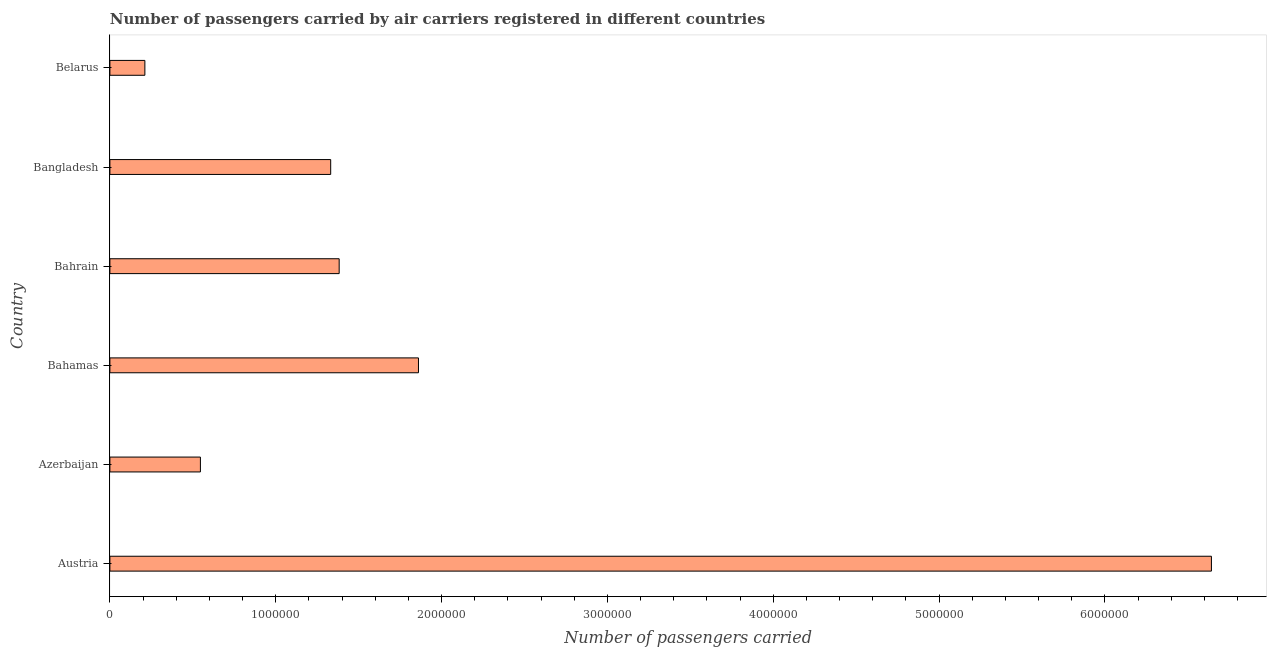Does the graph contain grids?
Give a very brief answer. No. What is the title of the graph?
Ensure brevity in your answer.  Number of passengers carried by air carriers registered in different countries. What is the label or title of the X-axis?
Your response must be concise. Number of passengers carried. What is the number of passengers carried in Azerbaijan?
Give a very brief answer. 5.46e+05. Across all countries, what is the maximum number of passengers carried?
Ensure brevity in your answer.  6.64e+06. Across all countries, what is the minimum number of passengers carried?
Give a very brief answer. 2.11e+05. In which country was the number of passengers carried maximum?
Provide a succinct answer. Austria. In which country was the number of passengers carried minimum?
Provide a succinct answer. Belarus. What is the sum of the number of passengers carried?
Provide a short and direct response. 1.20e+07. What is the difference between the number of passengers carried in Austria and Bahamas?
Keep it short and to the point. 4.78e+06. What is the average number of passengers carried per country?
Your response must be concise. 2.00e+06. What is the median number of passengers carried?
Make the answer very short. 1.36e+06. In how many countries, is the number of passengers carried greater than 6400000 ?
Keep it short and to the point. 1. What is the ratio of the number of passengers carried in Azerbaijan to that in Belarus?
Keep it short and to the point. 2.59. Is the number of passengers carried in Bangladesh less than that in Belarus?
Keep it short and to the point. No. Is the difference between the number of passengers carried in Bahamas and Bahrain greater than the difference between any two countries?
Provide a short and direct response. No. What is the difference between the highest and the second highest number of passengers carried?
Make the answer very short. 4.78e+06. What is the difference between the highest and the lowest number of passengers carried?
Your answer should be very brief. 6.43e+06. In how many countries, is the number of passengers carried greater than the average number of passengers carried taken over all countries?
Offer a very short reply. 1. How many countries are there in the graph?
Offer a very short reply. 6. What is the difference between two consecutive major ticks on the X-axis?
Keep it short and to the point. 1.00e+06. What is the Number of passengers carried of Austria?
Give a very brief answer. 6.64e+06. What is the Number of passengers carried in Azerbaijan?
Offer a terse response. 5.46e+05. What is the Number of passengers carried of Bahamas?
Give a very brief answer. 1.86e+06. What is the Number of passengers carried of Bahrain?
Provide a short and direct response. 1.38e+06. What is the Number of passengers carried in Bangladesh?
Give a very brief answer. 1.33e+06. What is the Number of passengers carried in Belarus?
Offer a very short reply. 2.11e+05. What is the difference between the Number of passengers carried in Austria and Azerbaijan?
Provide a succinct answer. 6.10e+06. What is the difference between the Number of passengers carried in Austria and Bahamas?
Your answer should be very brief. 4.78e+06. What is the difference between the Number of passengers carried in Austria and Bahrain?
Provide a short and direct response. 5.26e+06. What is the difference between the Number of passengers carried in Austria and Bangladesh?
Keep it short and to the point. 5.31e+06. What is the difference between the Number of passengers carried in Austria and Belarus?
Provide a succinct answer. 6.43e+06. What is the difference between the Number of passengers carried in Azerbaijan and Bahamas?
Make the answer very short. -1.31e+06. What is the difference between the Number of passengers carried in Azerbaijan and Bahrain?
Provide a short and direct response. -8.37e+05. What is the difference between the Number of passengers carried in Azerbaijan and Bangladesh?
Give a very brief answer. -7.86e+05. What is the difference between the Number of passengers carried in Azerbaijan and Belarus?
Offer a terse response. 3.35e+05. What is the difference between the Number of passengers carried in Bahamas and Bahrain?
Your answer should be compact. 4.78e+05. What is the difference between the Number of passengers carried in Bahamas and Bangladesh?
Your answer should be very brief. 5.29e+05. What is the difference between the Number of passengers carried in Bahamas and Belarus?
Offer a terse response. 1.65e+06. What is the difference between the Number of passengers carried in Bahrain and Bangladesh?
Ensure brevity in your answer.  5.11e+04. What is the difference between the Number of passengers carried in Bahrain and Belarus?
Offer a very short reply. 1.17e+06. What is the difference between the Number of passengers carried in Bangladesh and Belarus?
Keep it short and to the point. 1.12e+06. What is the ratio of the Number of passengers carried in Austria to that in Azerbaijan?
Provide a short and direct response. 12.17. What is the ratio of the Number of passengers carried in Austria to that in Bahamas?
Offer a very short reply. 3.57. What is the ratio of the Number of passengers carried in Austria to that in Bahrain?
Provide a succinct answer. 4.8. What is the ratio of the Number of passengers carried in Austria to that in Bangladesh?
Ensure brevity in your answer.  4.99. What is the ratio of the Number of passengers carried in Austria to that in Belarus?
Make the answer very short. 31.49. What is the ratio of the Number of passengers carried in Azerbaijan to that in Bahamas?
Your response must be concise. 0.29. What is the ratio of the Number of passengers carried in Azerbaijan to that in Bahrain?
Ensure brevity in your answer.  0.4. What is the ratio of the Number of passengers carried in Azerbaijan to that in Bangladesh?
Provide a short and direct response. 0.41. What is the ratio of the Number of passengers carried in Azerbaijan to that in Belarus?
Provide a succinct answer. 2.59. What is the ratio of the Number of passengers carried in Bahamas to that in Bahrain?
Give a very brief answer. 1.35. What is the ratio of the Number of passengers carried in Bahamas to that in Bangladesh?
Your answer should be compact. 1.4. What is the ratio of the Number of passengers carried in Bahamas to that in Belarus?
Your answer should be very brief. 8.82. What is the ratio of the Number of passengers carried in Bahrain to that in Bangladesh?
Your response must be concise. 1.04. What is the ratio of the Number of passengers carried in Bahrain to that in Belarus?
Your answer should be very brief. 6.55. What is the ratio of the Number of passengers carried in Bangladesh to that in Belarus?
Your answer should be very brief. 6.31. 